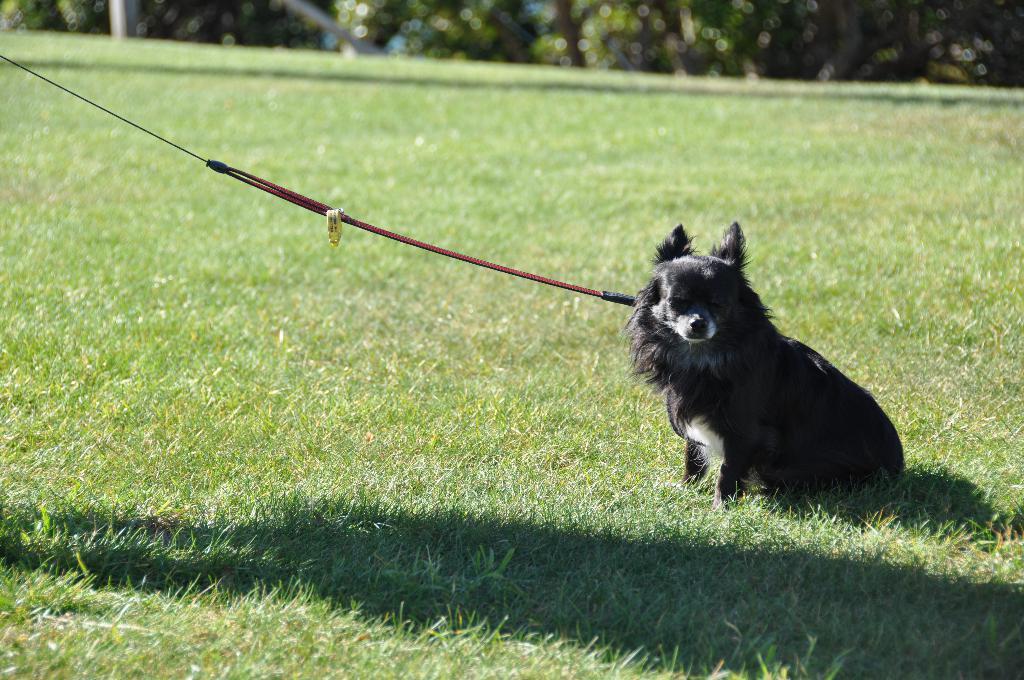Could you give a brief overview of what you see in this image? In this image we can see a dog on the ground which is tied with a rope. In the background we can see trees. 